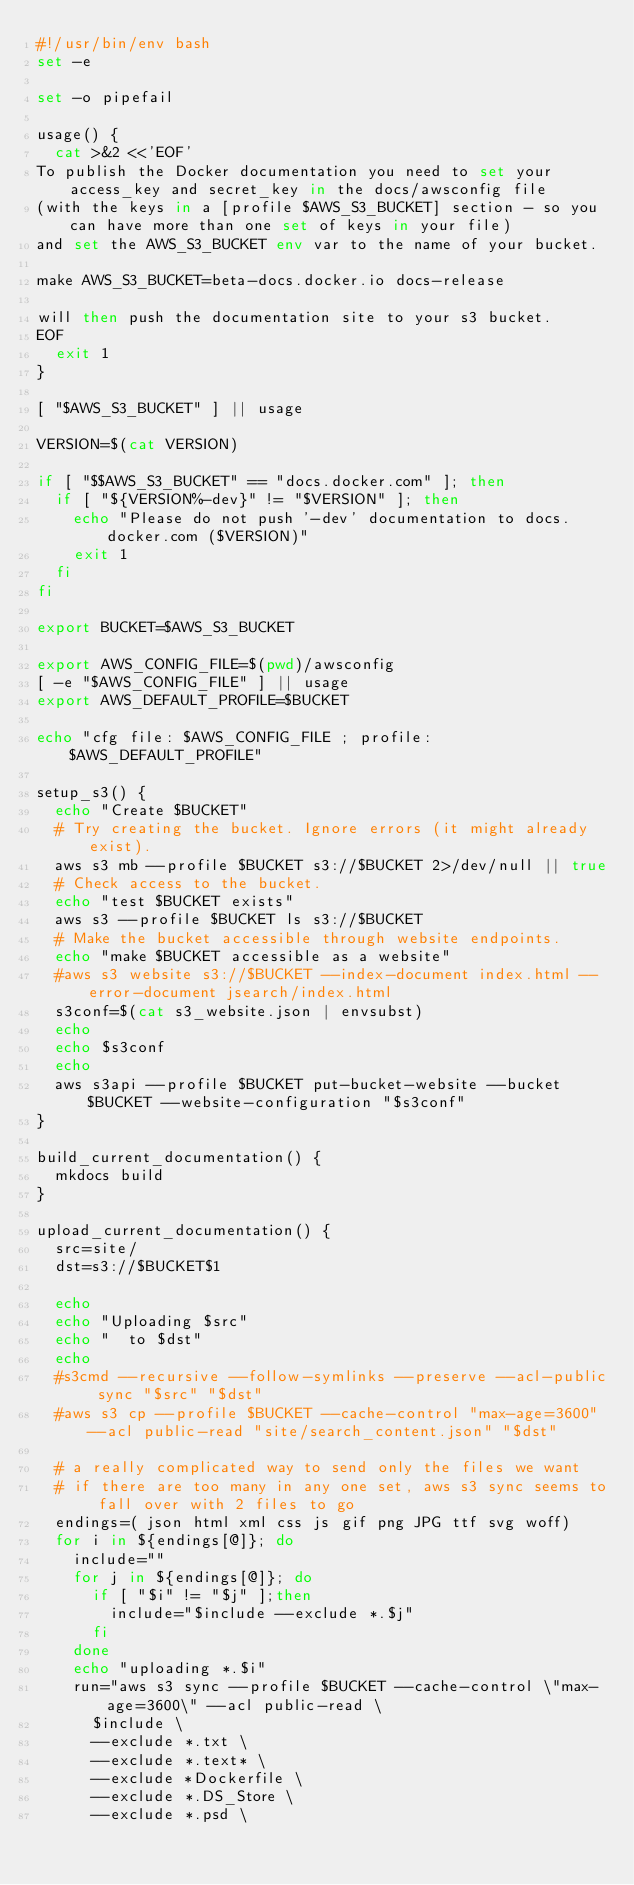Convert code to text. <code><loc_0><loc_0><loc_500><loc_500><_Bash_>#!/usr/bin/env bash
set -e

set -o pipefail

usage() {
	cat >&2 <<'EOF'
To publish the Docker documentation you need to set your access_key and secret_key in the docs/awsconfig file 
(with the keys in a [profile $AWS_S3_BUCKET] section - so you can have more than one set of keys in your file)
and set the AWS_S3_BUCKET env var to the name of your bucket.

make AWS_S3_BUCKET=beta-docs.docker.io docs-release

will then push the documentation site to your s3 bucket.
EOF
	exit 1
}

[ "$AWS_S3_BUCKET" ] || usage

VERSION=$(cat VERSION)

if [ "$$AWS_S3_BUCKET" == "docs.docker.com" ]; then
	if [ "${VERSION%-dev}" != "$VERSION" ]; then
		echo "Please do not push '-dev' documentation to docs.docker.com ($VERSION)"
		exit 1
	fi
fi

export BUCKET=$AWS_S3_BUCKET

export AWS_CONFIG_FILE=$(pwd)/awsconfig
[ -e "$AWS_CONFIG_FILE" ] || usage
export AWS_DEFAULT_PROFILE=$BUCKET

echo "cfg file: $AWS_CONFIG_FILE ; profile: $AWS_DEFAULT_PROFILE"

setup_s3() {
	echo "Create $BUCKET"
	# Try creating the bucket. Ignore errors (it might already exist).
	aws s3 mb --profile $BUCKET s3://$BUCKET 2>/dev/null || true
	# Check access to the bucket.
	echo "test $BUCKET exists"
	aws s3 --profile $BUCKET ls s3://$BUCKET
	# Make the bucket accessible through website endpoints.
	echo "make $BUCKET accessible as a website"
	#aws s3 website s3://$BUCKET --index-document index.html --error-document jsearch/index.html
	s3conf=$(cat s3_website.json | envsubst)
	echo
	echo $s3conf
	echo
	aws s3api --profile $BUCKET put-bucket-website --bucket $BUCKET --website-configuration "$s3conf"
}

build_current_documentation() {
	mkdocs build
}

upload_current_documentation() {
	src=site/
	dst=s3://$BUCKET$1

	echo
	echo "Uploading $src"
	echo "  to $dst"
	echo
	#s3cmd --recursive --follow-symlinks --preserve --acl-public sync "$src" "$dst"
	#aws s3 cp --profile $BUCKET --cache-control "max-age=3600" --acl public-read "site/search_content.json" "$dst"

	# a really complicated way to send only the files we want
	# if there are too many in any one set, aws s3 sync seems to fall over with 2 files to go
	endings=( json html xml css js gif png JPG ttf svg woff)
	for i in ${endings[@]}; do
		include=""
		for j in ${endings[@]}; do
			if [ "$i" != "$j" ];then
				include="$include --exclude *.$j"
			fi
		done
		echo "uploading *.$i"
		run="aws s3 sync --profile $BUCKET --cache-control \"max-age=3600\" --acl public-read \
			$include \
			--exclude *.txt \
			--exclude *.text* \
			--exclude *Dockerfile \
			--exclude *.DS_Store \
			--exclude *.psd \</code> 